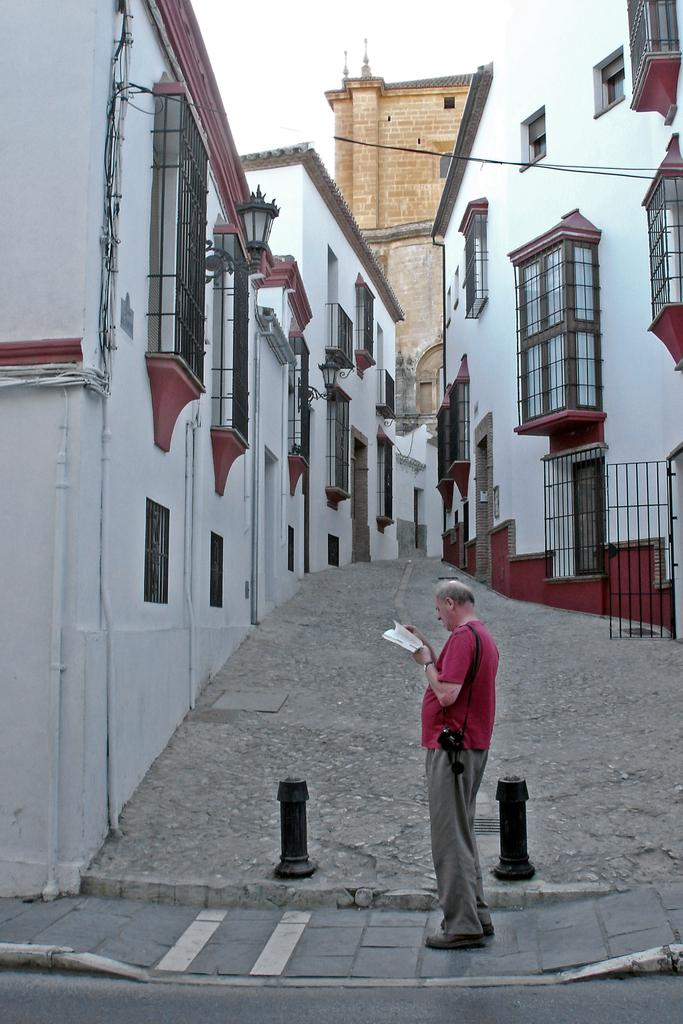What is the main subject of the image? There is a man standing in the image. Where is the man standing? The man is standing on a footpath. What can be seen in the background of the image? There are buildings in the image. What is the color of the buildings? The buildings are white in color. What type of books can be seen in the library in the image? There is no library present in the image; it features a man standing on a footpath with white buildings in the background. 